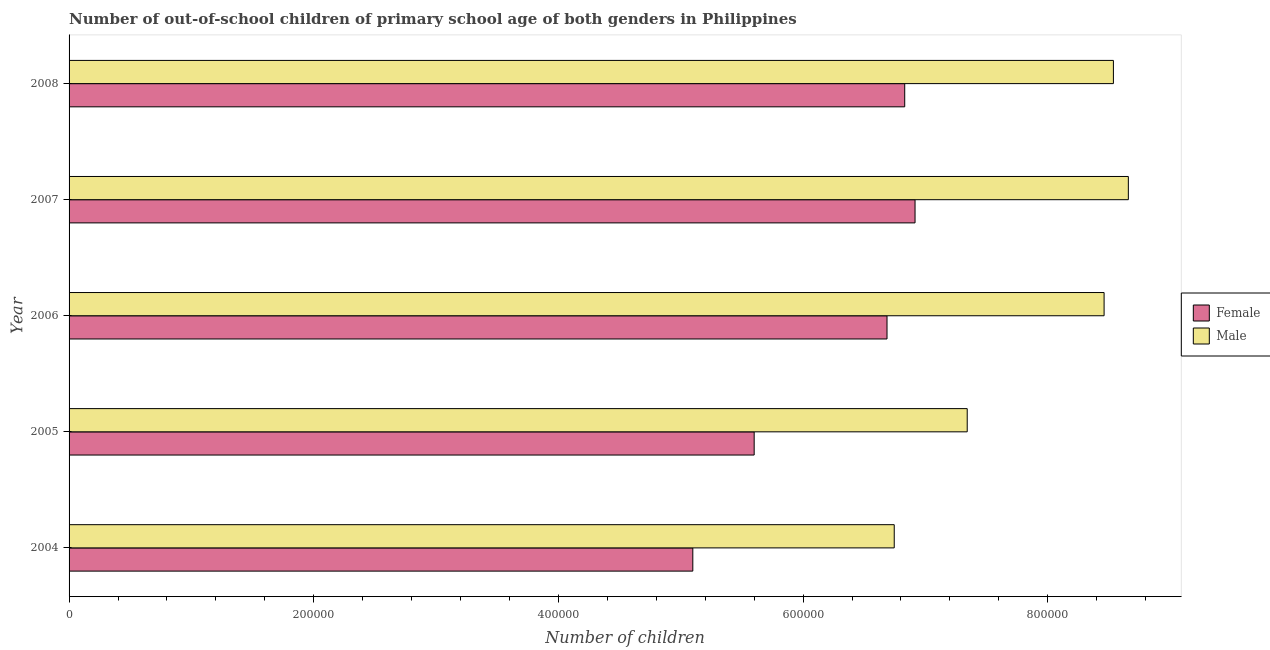How many different coloured bars are there?
Make the answer very short. 2. How many groups of bars are there?
Provide a short and direct response. 5. Are the number of bars on each tick of the Y-axis equal?
Make the answer very short. Yes. How many bars are there on the 4th tick from the top?
Make the answer very short. 2. In how many cases, is the number of bars for a given year not equal to the number of legend labels?
Ensure brevity in your answer.  0. What is the number of male out-of-school students in 2007?
Offer a very short reply. 8.66e+05. Across all years, what is the maximum number of female out-of-school students?
Your response must be concise. 6.92e+05. Across all years, what is the minimum number of female out-of-school students?
Your answer should be compact. 5.10e+05. What is the total number of male out-of-school students in the graph?
Keep it short and to the point. 3.97e+06. What is the difference between the number of female out-of-school students in 2007 and that in 2008?
Your answer should be very brief. 8438. What is the difference between the number of male out-of-school students in 2006 and the number of female out-of-school students in 2008?
Offer a very short reply. 1.63e+05. What is the average number of male out-of-school students per year?
Your answer should be very brief. 7.95e+05. In the year 2006, what is the difference between the number of male out-of-school students and number of female out-of-school students?
Offer a very short reply. 1.77e+05. In how many years, is the number of male out-of-school students greater than 400000 ?
Give a very brief answer. 5. What is the ratio of the number of male out-of-school students in 2004 to that in 2005?
Provide a short and direct response. 0.92. Is the number of female out-of-school students in 2005 less than that in 2008?
Offer a terse response. Yes. Is the difference between the number of female out-of-school students in 2005 and 2006 greater than the difference between the number of male out-of-school students in 2005 and 2006?
Offer a very short reply. Yes. What is the difference between the highest and the second highest number of female out-of-school students?
Provide a short and direct response. 8438. What is the difference between the highest and the lowest number of female out-of-school students?
Ensure brevity in your answer.  1.82e+05. What does the 1st bar from the bottom in 2004 represents?
Keep it short and to the point. Female. Are the values on the major ticks of X-axis written in scientific E-notation?
Keep it short and to the point. No. Where does the legend appear in the graph?
Your answer should be very brief. Center right. What is the title of the graph?
Make the answer very short. Number of out-of-school children of primary school age of both genders in Philippines. What is the label or title of the X-axis?
Your answer should be compact. Number of children. What is the label or title of the Y-axis?
Your response must be concise. Year. What is the Number of children in Female in 2004?
Your answer should be very brief. 5.10e+05. What is the Number of children in Male in 2004?
Provide a short and direct response. 6.74e+05. What is the Number of children in Female in 2005?
Provide a succinct answer. 5.60e+05. What is the Number of children in Male in 2005?
Offer a terse response. 7.34e+05. What is the Number of children in Female in 2006?
Offer a terse response. 6.69e+05. What is the Number of children of Male in 2006?
Your answer should be very brief. 8.46e+05. What is the Number of children in Female in 2007?
Make the answer very short. 6.92e+05. What is the Number of children in Male in 2007?
Make the answer very short. 8.66e+05. What is the Number of children of Female in 2008?
Your answer should be very brief. 6.83e+05. What is the Number of children in Male in 2008?
Give a very brief answer. 8.54e+05. Across all years, what is the maximum Number of children in Female?
Offer a terse response. 6.92e+05. Across all years, what is the maximum Number of children of Male?
Give a very brief answer. 8.66e+05. Across all years, what is the minimum Number of children in Female?
Your response must be concise. 5.10e+05. Across all years, what is the minimum Number of children of Male?
Ensure brevity in your answer.  6.74e+05. What is the total Number of children in Female in the graph?
Make the answer very short. 3.11e+06. What is the total Number of children of Male in the graph?
Your answer should be compact. 3.97e+06. What is the difference between the Number of children in Female in 2004 and that in 2005?
Offer a terse response. -5.02e+04. What is the difference between the Number of children of Male in 2004 and that in 2005?
Offer a very short reply. -5.97e+04. What is the difference between the Number of children in Female in 2004 and that in 2006?
Ensure brevity in your answer.  -1.59e+05. What is the difference between the Number of children in Male in 2004 and that in 2006?
Provide a short and direct response. -1.72e+05. What is the difference between the Number of children in Female in 2004 and that in 2007?
Make the answer very short. -1.82e+05. What is the difference between the Number of children of Male in 2004 and that in 2007?
Your answer should be very brief. -1.91e+05. What is the difference between the Number of children in Female in 2004 and that in 2008?
Give a very brief answer. -1.73e+05. What is the difference between the Number of children of Male in 2004 and that in 2008?
Provide a succinct answer. -1.79e+05. What is the difference between the Number of children in Female in 2005 and that in 2006?
Provide a succinct answer. -1.09e+05. What is the difference between the Number of children in Male in 2005 and that in 2006?
Your answer should be very brief. -1.12e+05. What is the difference between the Number of children of Female in 2005 and that in 2007?
Keep it short and to the point. -1.31e+05. What is the difference between the Number of children of Male in 2005 and that in 2007?
Make the answer very short. -1.32e+05. What is the difference between the Number of children of Female in 2005 and that in 2008?
Make the answer very short. -1.23e+05. What is the difference between the Number of children of Male in 2005 and that in 2008?
Your answer should be very brief. -1.20e+05. What is the difference between the Number of children in Female in 2006 and that in 2007?
Provide a short and direct response. -2.29e+04. What is the difference between the Number of children of Male in 2006 and that in 2007?
Offer a terse response. -1.98e+04. What is the difference between the Number of children of Female in 2006 and that in 2008?
Ensure brevity in your answer.  -1.45e+04. What is the difference between the Number of children in Male in 2006 and that in 2008?
Your response must be concise. -7606. What is the difference between the Number of children of Female in 2007 and that in 2008?
Make the answer very short. 8438. What is the difference between the Number of children of Male in 2007 and that in 2008?
Make the answer very short. 1.22e+04. What is the difference between the Number of children in Female in 2004 and the Number of children in Male in 2005?
Ensure brevity in your answer.  -2.24e+05. What is the difference between the Number of children of Female in 2004 and the Number of children of Male in 2006?
Provide a succinct answer. -3.36e+05. What is the difference between the Number of children in Female in 2004 and the Number of children in Male in 2007?
Ensure brevity in your answer.  -3.56e+05. What is the difference between the Number of children in Female in 2004 and the Number of children in Male in 2008?
Provide a succinct answer. -3.44e+05. What is the difference between the Number of children in Female in 2005 and the Number of children in Male in 2006?
Offer a terse response. -2.86e+05. What is the difference between the Number of children in Female in 2005 and the Number of children in Male in 2007?
Provide a succinct answer. -3.06e+05. What is the difference between the Number of children of Female in 2005 and the Number of children of Male in 2008?
Provide a succinct answer. -2.94e+05. What is the difference between the Number of children of Female in 2006 and the Number of children of Male in 2007?
Offer a terse response. -1.97e+05. What is the difference between the Number of children of Female in 2006 and the Number of children of Male in 2008?
Offer a terse response. -1.85e+05. What is the difference between the Number of children of Female in 2007 and the Number of children of Male in 2008?
Offer a very short reply. -1.62e+05. What is the average Number of children of Female per year?
Give a very brief answer. 6.23e+05. What is the average Number of children in Male per year?
Provide a short and direct response. 7.95e+05. In the year 2004, what is the difference between the Number of children in Female and Number of children in Male?
Offer a very short reply. -1.65e+05. In the year 2005, what is the difference between the Number of children of Female and Number of children of Male?
Give a very brief answer. -1.74e+05. In the year 2006, what is the difference between the Number of children in Female and Number of children in Male?
Offer a very short reply. -1.77e+05. In the year 2007, what is the difference between the Number of children in Female and Number of children in Male?
Give a very brief answer. -1.74e+05. In the year 2008, what is the difference between the Number of children of Female and Number of children of Male?
Offer a terse response. -1.71e+05. What is the ratio of the Number of children of Female in 2004 to that in 2005?
Offer a very short reply. 0.91. What is the ratio of the Number of children of Male in 2004 to that in 2005?
Ensure brevity in your answer.  0.92. What is the ratio of the Number of children in Female in 2004 to that in 2006?
Keep it short and to the point. 0.76. What is the ratio of the Number of children in Male in 2004 to that in 2006?
Provide a short and direct response. 0.8. What is the ratio of the Number of children of Female in 2004 to that in 2007?
Offer a very short reply. 0.74. What is the ratio of the Number of children in Male in 2004 to that in 2007?
Offer a terse response. 0.78. What is the ratio of the Number of children of Female in 2004 to that in 2008?
Give a very brief answer. 0.75. What is the ratio of the Number of children in Male in 2004 to that in 2008?
Give a very brief answer. 0.79. What is the ratio of the Number of children of Female in 2005 to that in 2006?
Offer a very short reply. 0.84. What is the ratio of the Number of children of Male in 2005 to that in 2006?
Ensure brevity in your answer.  0.87. What is the ratio of the Number of children of Female in 2005 to that in 2007?
Your answer should be compact. 0.81. What is the ratio of the Number of children in Male in 2005 to that in 2007?
Provide a short and direct response. 0.85. What is the ratio of the Number of children of Female in 2005 to that in 2008?
Offer a very short reply. 0.82. What is the ratio of the Number of children in Male in 2005 to that in 2008?
Ensure brevity in your answer.  0.86. What is the ratio of the Number of children of Female in 2006 to that in 2007?
Offer a very short reply. 0.97. What is the ratio of the Number of children of Male in 2006 to that in 2007?
Provide a succinct answer. 0.98. What is the ratio of the Number of children of Female in 2006 to that in 2008?
Your response must be concise. 0.98. What is the ratio of the Number of children of Female in 2007 to that in 2008?
Offer a terse response. 1.01. What is the ratio of the Number of children of Male in 2007 to that in 2008?
Make the answer very short. 1.01. What is the difference between the highest and the second highest Number of children of Female?
Your answer should be very brief. 8438. What is the difference between the highest and the second highest Number of children of Male?
Make the answer very short. 1.22e+04. What is the difference between the highest and the lowest Number of children of Female?
Your answer should be very brief. 1.82e+05. What is the difference between the highest and the lowest Number of children in Male?
Your answer should be very brief. 1.91e+05. 